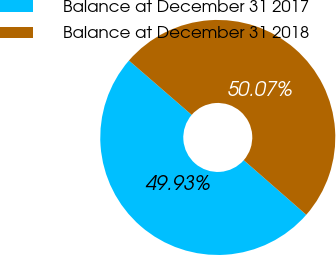Convert chart. <chart><loc_0><loc_0><loc_500><loc_500><pie_chart><fcel>Balance at December 31 2017<fcel>Balance at December 31 2018<nl><fcel>49.93%<fcel>50.07%<nl></chart> 